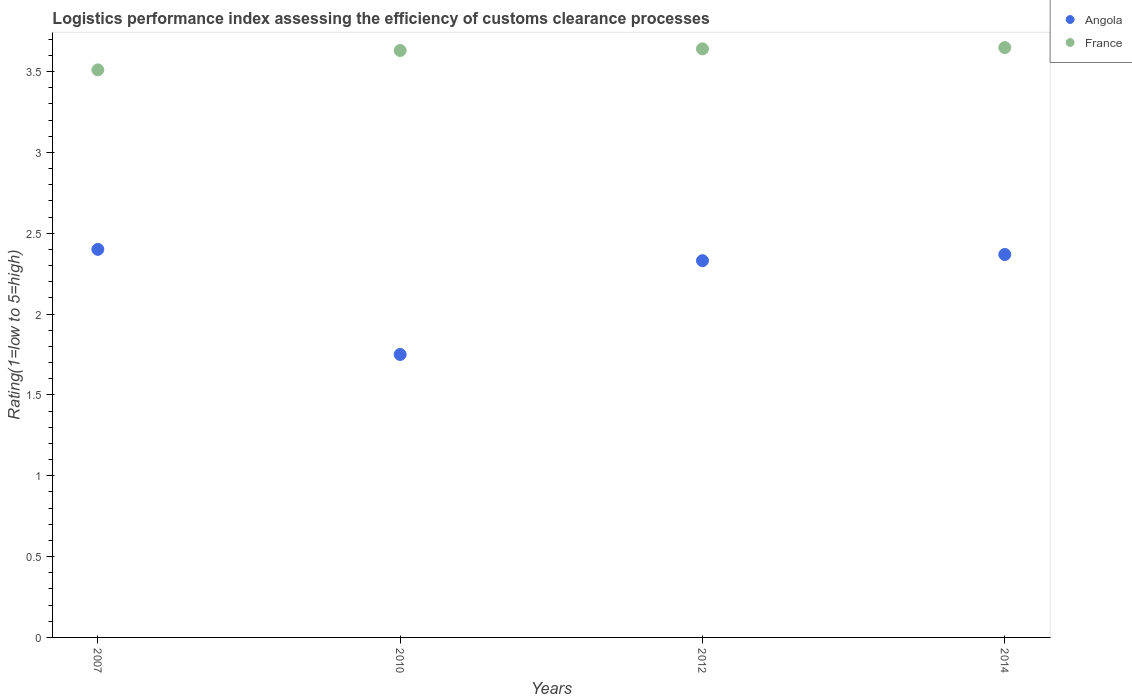Is the number of dotlines equal to the number of legend labels?
Give a very brief answer. Yes. What is the Logistic performance index in Angola in 2012?
Provide a short and direct response. 2.33. In which year was the Logistic performance index in France minimum?
Provide a succinct answer. 2007. What is the total Logistic performance index in Angola in the graph?
Offer a terse response. 8.85. What is the difference between the Logistic performance index in Angola in 2012 and that in 2014?
Provide a short and direct response. -0.04. What is the difference between the Logistic performance index in Angola in 2014 and the Logistic performance index in France in 2010?
Offer a terse response. -1.26. What is the average Logistic performance index in Angola per year?
Provide a succinct answer. 2.21. In the year 2014, what is the difference between the Logistic performance index in Angola and Logistic performance index in France?
Give a very brief answer. -1.28. In how many years, is the Logistic performance index in Angola greater than 2?
Make the answer very short. 3. What is the ratio of the Logistic performance index in Angola in 2010 to that in 2012?
Provide a short and direct response. 0.75. Is the Logistic performance index in Angola in 2007 less than that in 2012?
Your response must be concise. No. What is the difference between the highest and the second highest Logistic performance index in France?
Your response must be concise. 0.01. What is the difference between the highest and the lowest Logistic performance index in France?
Provide a short and direct response. 0.14. In how many years, is the Logistic performance index in Angola greater than the average Logistic performance index in Angola taken over all years?
Offer a terse response. 3. Is the sum of the Logistic performance index in Angola in 2010 and 2014 greater than the maximum Logistic performance index in France across all years?
Give a very brief answer. Yes. Is the Logistic performance index in France strictly greater than the Logistic performance index in Angola over the years?
Your answer should be compact. Yes. Is the Logistic performance index in Angola strictly less than the Logistic performance index in France over the years?
Make the answer very short. Yes. How many dotlines are there?
Keep it short and to the point. 2. Does the graph contain any zero values?
Your answer should be compact. No. Where does the legend appear in the graph?
Keep it short and to the point. Top right. What is the title of the graph?
Your response must be concise. Logistics performance index assessing the efficiency of customs clearance processes. What is the label or title of the Y-axis?
Keep it short and to the point. Rating(1=low to 5=high). What is the Rating(1=low to 5=high) in Angola in 2007?
Provide a succinct answer. 2.4. What is the Rating(1=low to 5=high) of France in 2007?
Offer a very short reply. 3.51. What is the Rating(1=low to 5=high) of France in 2010?
Ensure brevity in your answer.  3.63. What is the Rating(1=low to 5=high) in Angola in 2012?
Your response must be concise. 2.33. What is the Rating(1=low to 5=high) of France in 2012?
Keep it short and to the point. 3.64. What is the Rating(1=low to 5=high) in Angola in 2014?
Provide a succinct answer. 2.37. What is the Rating(1=low to 5=high) of France in 2014?
Your response must be concise. 3.65. Across all years, what is the maximum Rating(1=low to 5=high) of Angola?
Make the answer very short. 2.4. Across all years, what is the maximum Rating(1=low to 5=high) of France?
Provide a succinct answer. 3.65. Across all years, what is the minimum Rating(1=low to 5=high) in France?
Keep it short and to the point. 3.51. What is the total Rating(1=low to 5=high) of Angola in the graph?
Keep it short and to the point. 8.85. What is the total Rating(1=low to 5=high) in France in the graph?
Your response must be concise. 14.43. What is the difference between the Rating(1=low to 5=high) in Angola in 2007 and that in 2010?
Offer a very short reply. 0.65. What is the difference between the Rating(1=low to 5=high) in France in 2007 and that in 2010?
Ensure brevity in your answer.  -0.12. What is the difference between the Rating(1=low to 5=high) in Angola in 2007 and that in 2012?
Keep it short and to the point. 0.07. What is the difference between the Rating(1=low to 5=high) in France in 2007 and that in 2012?
Offer a very short reply. -0.13. What is the difference between the Rating(1=low to 5=high) of Angola in 2007 and that in 2014?
Offer a very short reply. 0.03. What is the difference between the Rating(1=low to 5=high) in France in 2007 and that in 2014?
Offer a very short reply. -0.14. What is the difference between the Rating(1=low to 5=high) in Angola in 2010 and that in 2012?
Your answer should be compact. -0.58. What is the difference between the Rating(1=low to 5=high) in France in 2010 and that in 2012?
Provide a short and direct response. -0.01. What is the difference between the Rating(1=low to 5=high) in Angola in 2010 and that in 2014?
Your answer should be very brief. -0.62. What is the difference between the Rating(1=low to 5=high) of France in 2010 and that in 2014?
Your answer should be very brief. -0.02. What is the difference between the Rating(1=low to 5=high) of Angola in 2012 and that in 2014?
Your answer should be compact. -0.04. What is the difference between the Rating(1=low to 5=high) in France in 2012 and that in 2014?
Your answer should be compact. -0.01. What is the difference between the Rating(1=low to 5=high) in Angola in 2007 and the Rating(1=low to 5=high) in France in 2010?
Keep it short and to the point. -1.23. What is the difference between the Rating(1=low to 5=high) in Angola in 2007 and the Rating(1=low to 5=high) in France in 2012?
Provide a short and direct response. -1.24. What is the difference between the Rating(1=low to 5=high) of Angola in 2007 and the Rating(1=low to 5=high) of France in 2014?
Provide a short and direct response. -1.25. What is the difference between the Rating(1=low to 5=high) of Angola in 2010 and the Rating(1=low to 5=high) of France in 2012?
Your answer should be compact. -1.89. What is the difference between the Rating(1=low to 5=high) of Angola in 2010 and the Rating(1=low to 5=high) of France in 2014?
Your answer should be very brief. -1.9. What is the difference between the Rating(1=low to 5=high) of Angola in 2012 and the Rating(1=low to 5=high) of France in 2014?
Offer a very short reply. -1.32. What is the average Rating(1=low to 5=high) of Angola per year?
Provide a short and direct response. 2.21. What is the average Rating(1=low to 5=high) in France per year?
Ensure brevity in your answer.  3.61. In the year 2007, what is the difference between the Rating(1=low to 5=high) of Angola and Rating(1=low to 5=high) of France?
Keep it short and to the point. -1.11. In the year 2010, what is the difference between the Rating(1=low to 5=high) of Angola and Rating(1=low to 5=high) of France?
Keep it short and to the point. -1.88. In the year 2012, what is the difference between the Rating(1=low to 5=high) of Angola and Rating(1=low to 5=high) of France?
Offer a very short reply. -1.31. In the year 2014, what is the difference between the Rating(1=low to 5=high) in Angola and Rating(1=low to 5=high) in France?
Your response must be concise. -1.28. What is the ratio of the Rating(1=low to 5=high) of Angola in 2007 to that in 2010?
Offer a terse response. 1.37. What is the ratio of the Rating(1=low to 5=high) of France in 2007 to that in 2010?
Offer a very short reply. 0.97. What is the ratio of the Rating(1=low to 5=high) of France in 2007 to that in 2012?
Provide a short and direct response. 0.96. What is the ratio of the Rating(1=low to 5=high) of Angola in 2007 to that in 2014?
Your response must be concise. 1.01. What is the ratio of the Rating(1=low to 5=high) in France in 2007 to that in 2014?
Offer a terse response. 0.96. What is the ratio of the Rating(1=low to 5=high) of Angola in 2010 to that in 2012?
Offer a very short reply. 0.75. What is the ratio of the Rating(1=low to 5=high) of Angola in 2010 to that in 2014?
Make the answer very short. 0.74. What is the ratio of the Rating(1=low to 5=high) in France in 2010 to that in 2014?
Your answer should be compact. 1. What is the ratio of the Rating(1=low to 5=high) of Angola in 2012 to that in 2014?
Offer a very short reply. 0.98. What is the difference between the highest and the second highest Rating(1=low to 5=high) of Angola?
Offer a terse response. 0.03. What is the difference between the highest and the second highest Rating(1=low to 5=high) in France?
Provide a short and direct response. 0.01. What is the difference between the highest and the lowest Rating(1=low to 5=high) of Angola?
Keep it short and to the point. 0.65. What is the difference between the highest and the lowest Rating(1=low to 5=high) in France?
Your response must be concise. 0.14. 